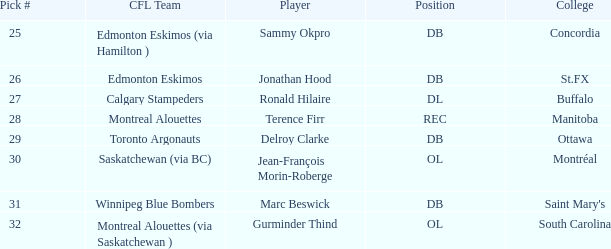What is buffalo's pick #? 27.0. 